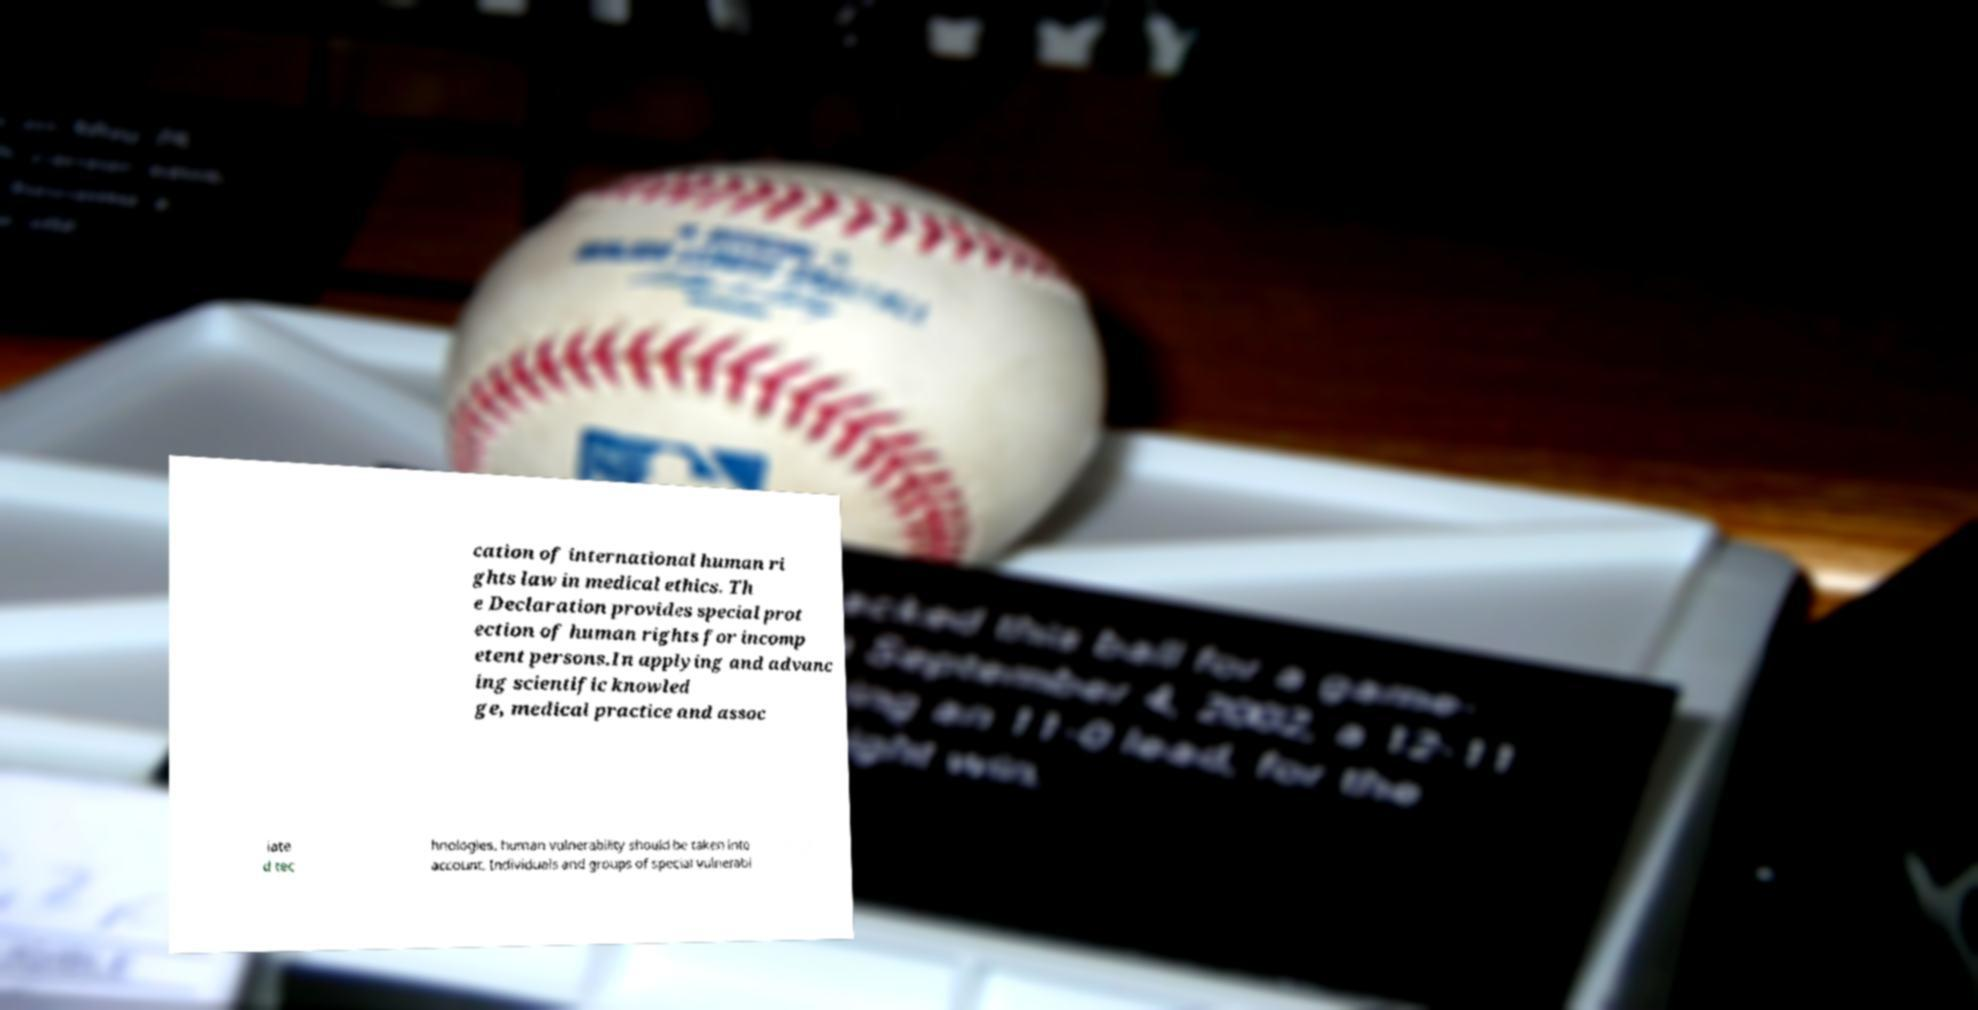What messages or text are displayed in this image? I need them in a readable, typed format. cation of international human ri ghts law in medical ethics. Th e Declaration provides special prot ection of human rights for incomp etent persons.In applying and advanc ing scientific knowled ge, medical practice and assoc iate d tec hnologies, human vulnerability should be taken into account. Individuals and groups of special vulnerabi 